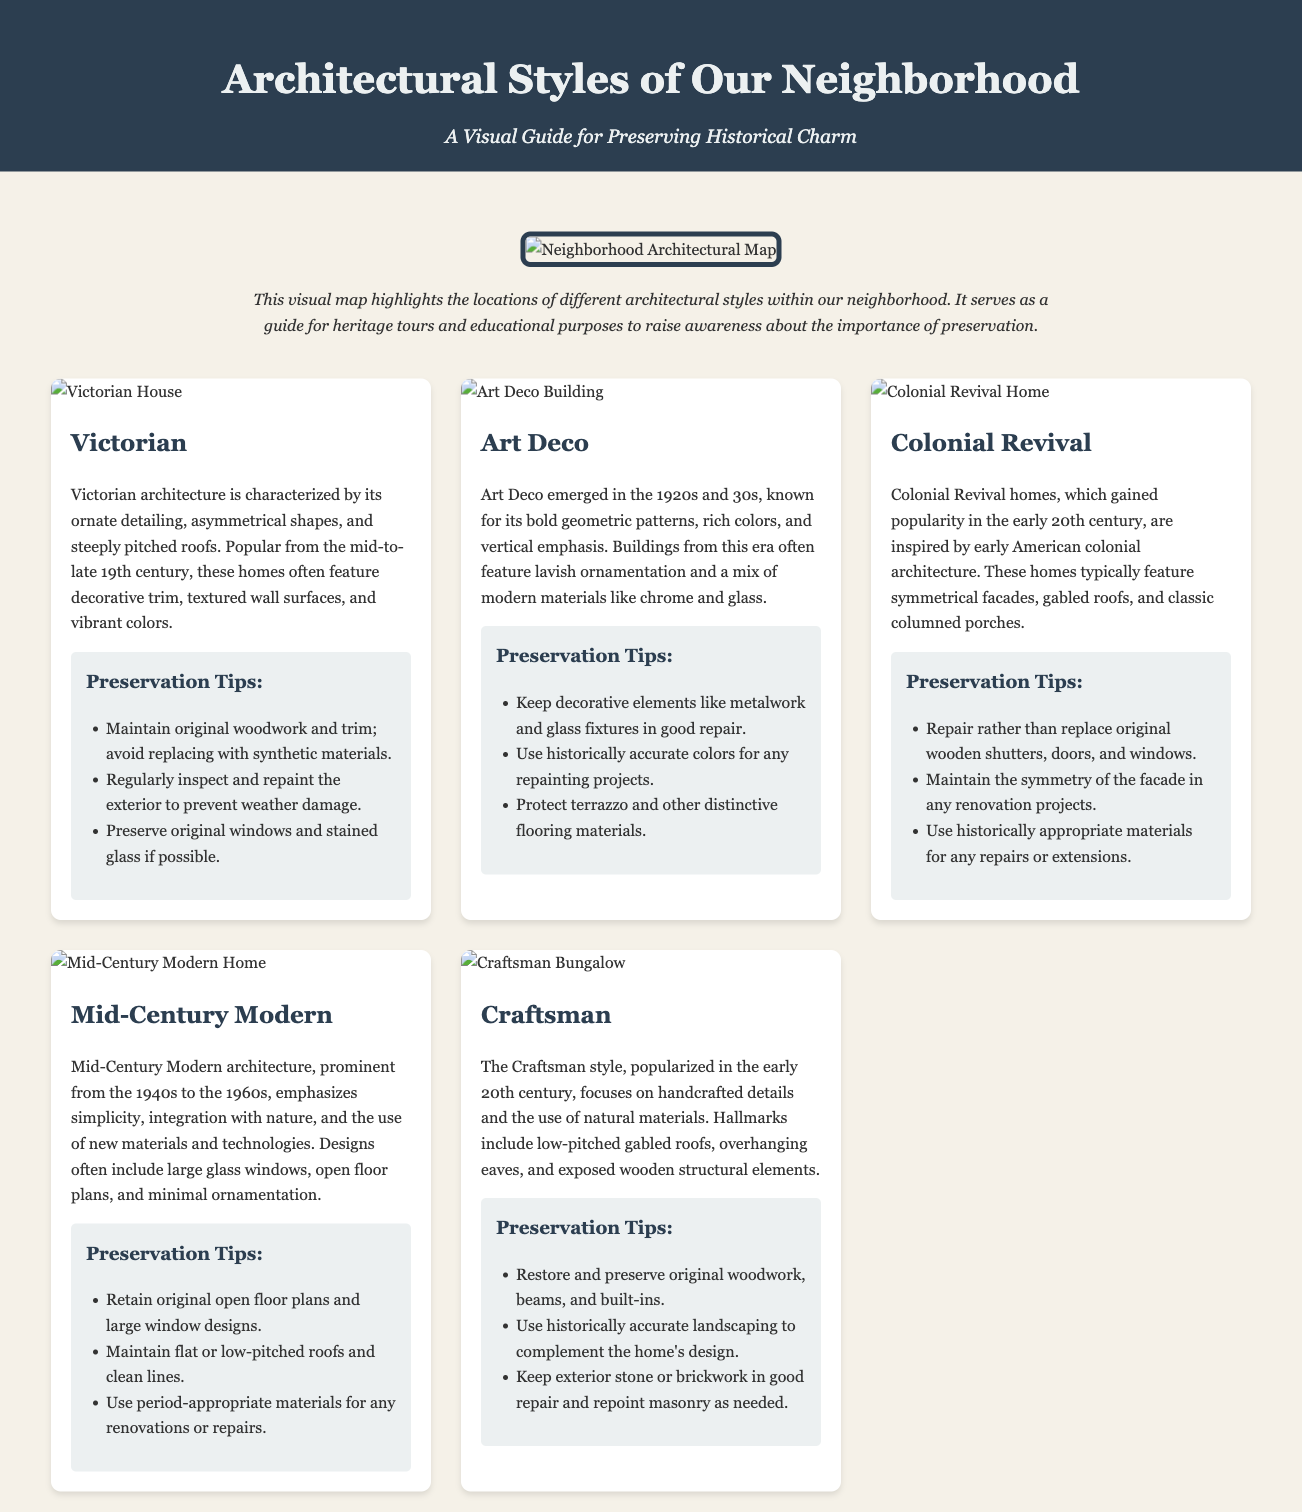what is the main title of the document? The main title is displayed prominently at the top of the document.
Answer: Architectural Styles of Our Neighborhood how many architectural styles are featured in the document? Each style card represents a different architectural style, and there are five style cards.
Answer: Five what is a key characteristic of Victorian architecture? The document describes the Victorian style and lists its characteristics in the description section.
Answer: Ornate detailing what are the preservation tips for Art Deco buildings? The preservation tips for Art Deco buildings are listed under their respective style card.
Answer: Keep decorative elements like metalwork what style is known for its integration with nature? A brief overview of each architectural style describes key themes; Mid-Century Modern is known for this.
Answer: Mid-Century Modern which architectural style emphasizes handcrafted details? The description section of the Craftsman style card indicates its focus on craftsmanship.
Answer: Craftsman what decade is Mid-Century Modern architecture prominent? The document specifies the timeline of the styles, particularly for Mid-Century Modern.
Answer: 1940s to 1960s which element is crucial for preserving Colonial Revival homes? Important elements for preservation are outlined in their respective style cards.
Answer: Original wooden shutters where can one find a visual map of the neighborhood's architecture? The visual map section at the beginning of the document showcases architectural locations.
Answer: In the map section 